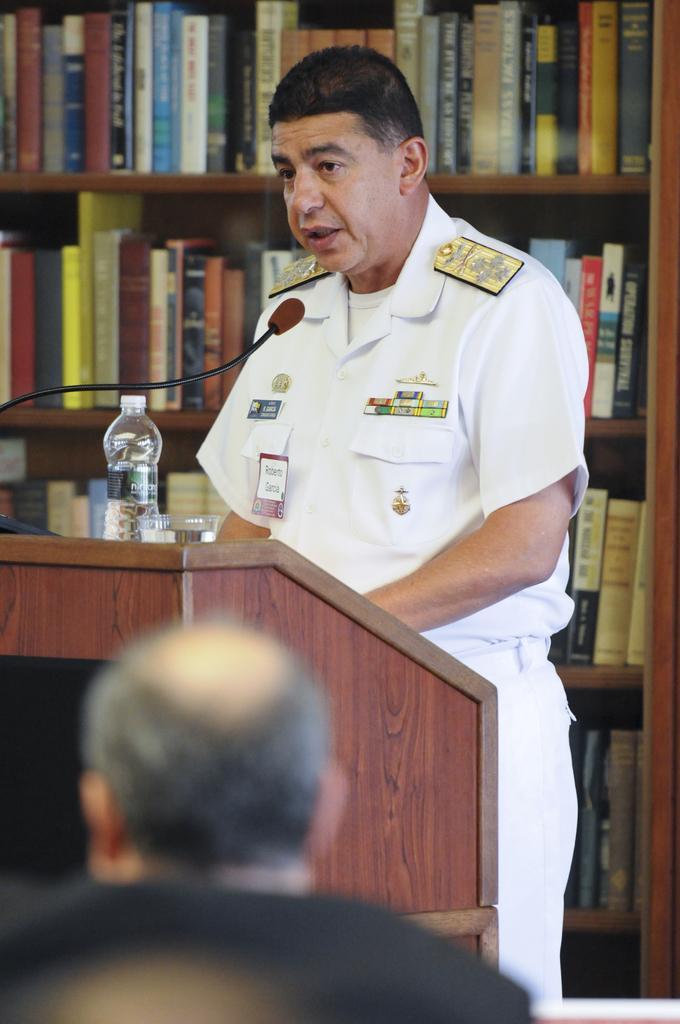Please provide a concise description of this image. Here a man is wearing a white color dress standing near the podium and speaking on a microphone there is a water bottle on this. A person is wearing a black color dress right side of an image there are books in a shelf. 